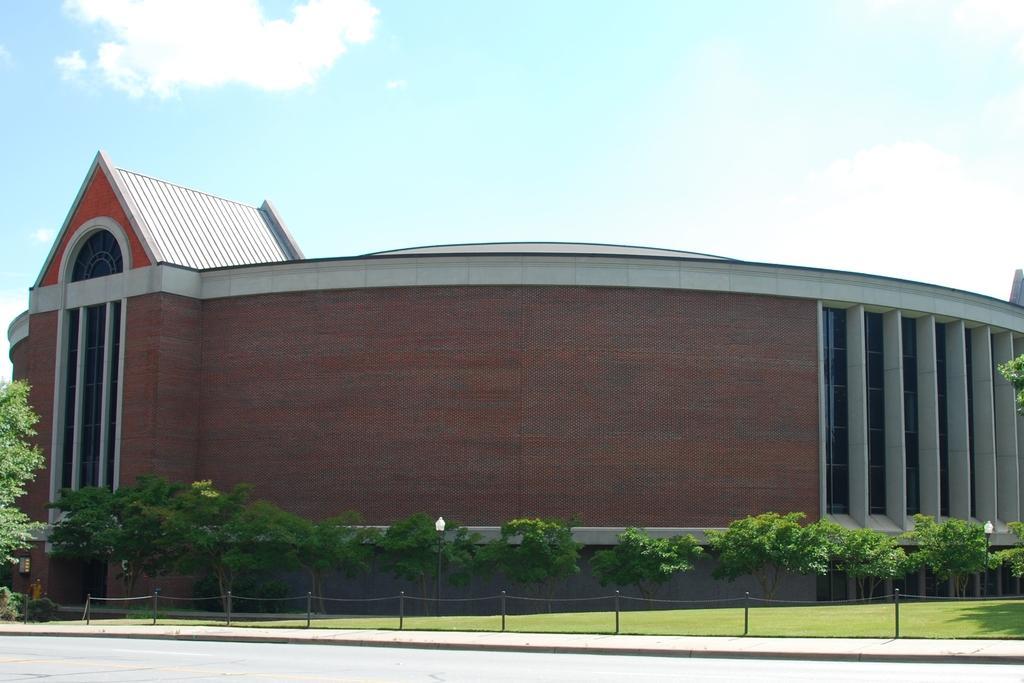Could you give a brief overview of what you see in this image? At the bottom of the picture, we see the road. In the middle, we see the fence, grass, trees and a street light. There are trees and a building in the background. At the top, we see the sky and the clouds. 